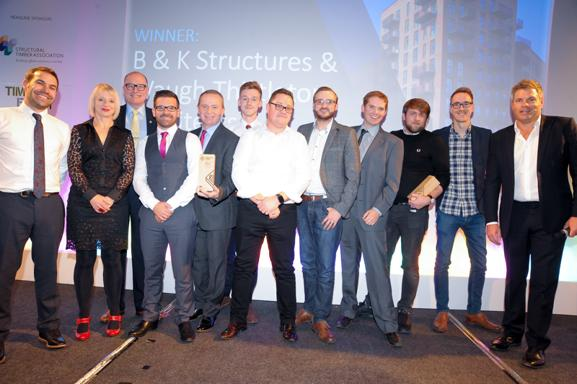Can you tell me about the people on stage? The image shows a group of 11 individuals on a stage, presumably at an awards ceremony, given the 'WINNER' backdrop and a trophy being held by one of the individuals. This setting suggests they are likely professionals celebrated for their achievements in their respective field, which could be related to 'B & K Structures & noughty.' Each person displays a joyful and proud expression, contributing to the celebratory atmosphere of the event. 